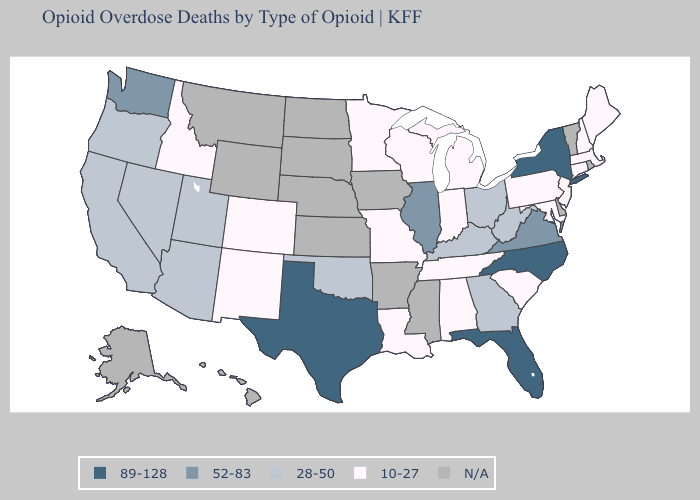Name the states that have a value in the range N/A?
Give a very brief answer. Alaska, Arkansas, Delaware, Hawaii, Iowa, Kansas, Mississippi, Montana, Nebraska, North Dakota, Rhode Island, South Dakota, Vermont, Wyoming. Name the states that have a value in the range N/A?
Write a very short answer. Alaska, Arkansas, Delaware, Hawaii, Iowa, Kansas, Mississippi, Montana, Nebraska, North Dakota, Rhode Island, South Dakota, Vermont, Wyoming. What is the lowest value in states that border North Carolina?
Be succinct. 10-27. Name the states that have a value in the range 28-50?
Write a very short answer. Arizona, California, Georgia, Kentucky, Nevada, Ohio, Oklahoma, Oregon, Utah, West Virginia. What is the highest value in the USA?
Answer briefly. 89-128. What is the value of Georgia?
Concise answer only. 28-50. What is the highest value in the USA?
Be succinct. 89-128. What is the highest value in states that border Idaho?
Short answer required. 52-83. Which states have the lowest value in the USA?
Concise answer only. Alabama, Colorado, Connecticut, Idaho, Indiana, Louisiana, Maine, Maryland, Massachusetts, Michigan, Minnesota, Missouri, New Hampshire, New Jersey, New Mexico, Pennsylvania, South Carolina, Tennessee, Wisconsin. Does the first symbol in the legend represent the smallest category?
Write a very short answer. No. What is the value of Pennsylvania?
Answer briefly. 10-27. What is the value of Pennsylvania?
Keep it brief. 10-27. What is the highest value in the Northeast ?
Answer briefly. 89-128. What is the value of Rhode Island?
Write a very short answer. N/A. Which states have the highest value in the USA?
Short answer required. Florida, New York, North Carolina, Texas. 